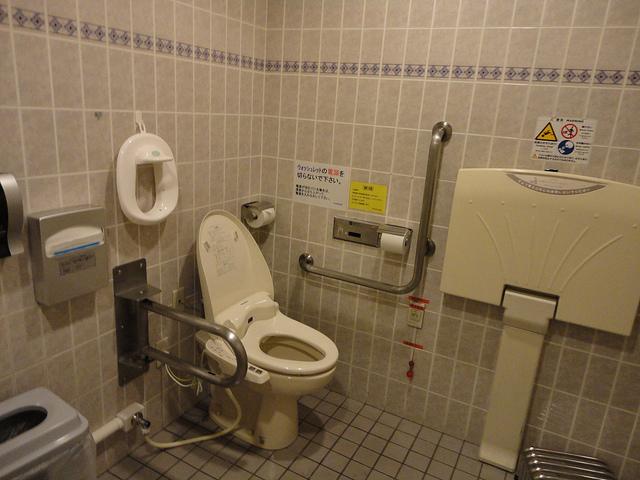Is the toilet seat up or down?
Concise answer only. Up. Are the signs in a foreign language?
Quick response, please. Yes. What color is the toilet seat?
Keep it brief. White. What are the bars next to the toilet for?
Give a very brief answer. Handicap. What is the toilet seat made out of?
Answer briefly. Plastic. 